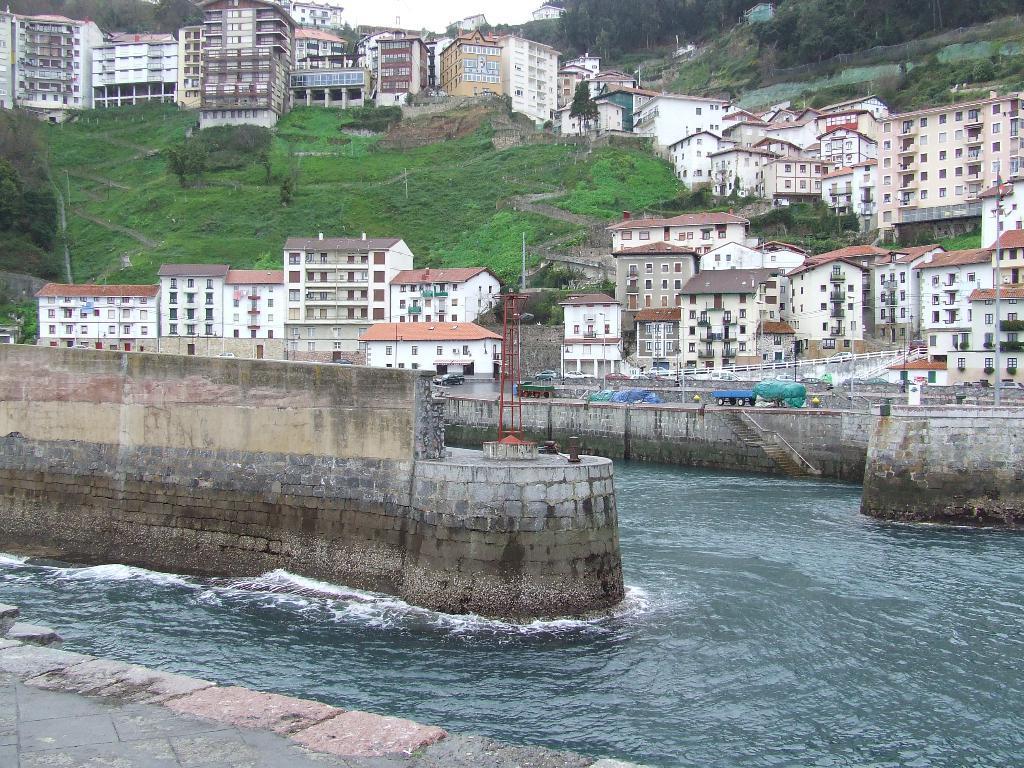Could you give a brief overview of what you see in this image? At the bottom of the picture, we see a pavement and the water. This water might be in the river. Beside that, we see a wall and sheets in blue and green color. There are trees, buildings and grass in the background. At the top, we see a hill. 